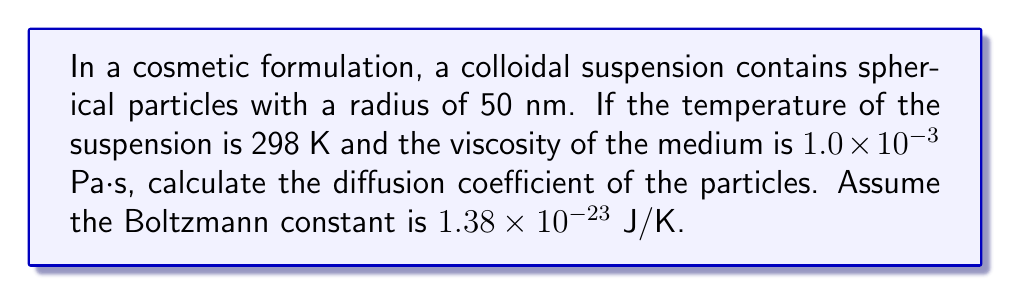Teach me how to tackle this problem. To calculate the diffusion coefficient of particles in a colloidal suspension, we can use the Stokes-Einstein equation:

$$D = \frac{k_B T}{6\pi \eta r}$$

Where:
$D$ = Diffusion coefficient
$k_B$ = Boltzmann constant
$T$ = Temperature
$\eta$ = Viscosity of the medium
$r$ = Radius of the particles

Given:
$k_B = 1.38 \times 10^{-23}$ J/K
$T = 298$ K
$\eta = 1.0 \times 10^{-3}$ Pa·s
$r = 50 \times 10^{-9}$ m

Step 1: Substitute the values into the Stokes-Einstein equation:

$$D = \frac{(1.38 \times 10^{-23})(298)}{6\pi(1.0 \times 10^{-3})(50 \times 10^{-9})}$$

Step 2: Calculate the numerator:
$1.38 \times 10^{-23} \times 298 = 4.1124 \times 10^{-21}$

Step 3: Calculate the denominator:
$6\pi \times 1.0 \times 10^{-3} \times 50 \times 10^{-9} = 9.4248 \times 10^{-10}$

Step 4: Divide the numerator by the denominator:
$$D = \frac{4.1124 \times 10^{-21}}{9.4248 \times 10^{-10}} = 4.3633 \times 10^{-12}$$

Step 5: Round to three significant figures and express in scientific notation:
$D = 4.36 \times 10^{-12}$ m²/s
Answer: $4.36 \times 10^{-12}$ m²/s 